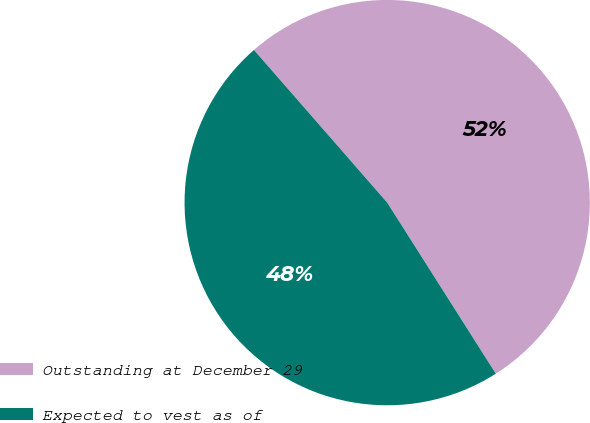<chart> <loc_0><loc_0><loc_500><loc_500><pie_chart><fcel>Outstanding at December 29<fcel>Expected to vest as of<nl><fcel>52.42%<fcel>47.58%<nl></chart> 